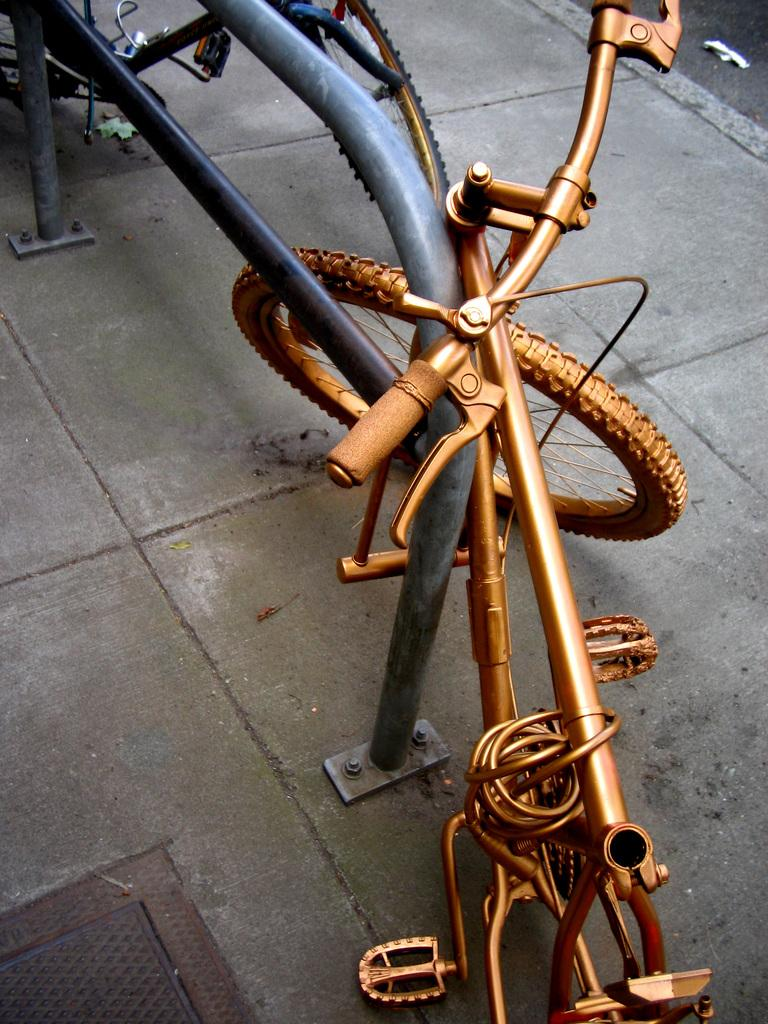What type of vehicles are present in the image? There are bicycles in the image. What material is used to make the metallic object in the image? The metallic object in the image is made of metal. Where is the metal lid located in the image? The metal lid is at the bottom of the image. How many women are sleeping with a baby in the image? There are no women, sleeping or otherwise, nor any babies present in the image. 